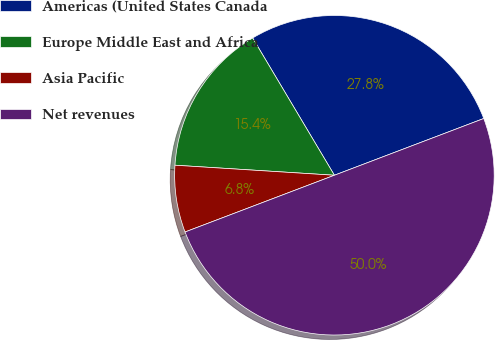Convert chart to OTSL. <chart><loc_0><loc_0><loc_500><loc_500><pie_chart><fcel>Americas (United States Canada<fcel>Europe Middle East and Africa<fcel>Asia Pacific<fcel>Net revenues<nl><fcel>27.77%<fcel>15.45%<fcel>6.78%<fcel>50.0%<nl></chart> 